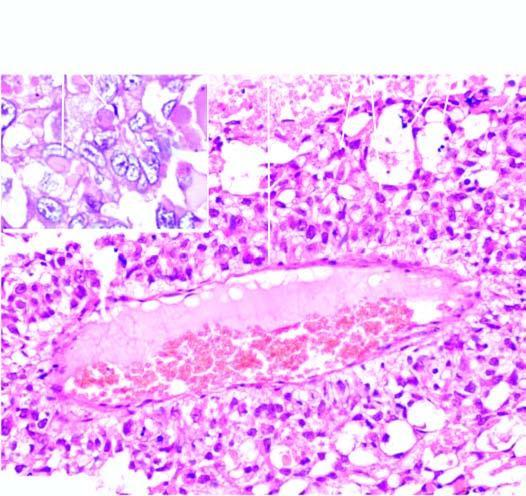what does inset show?
Answer the question using a single word or phrase. Intra- and extracellular hyaline globules 